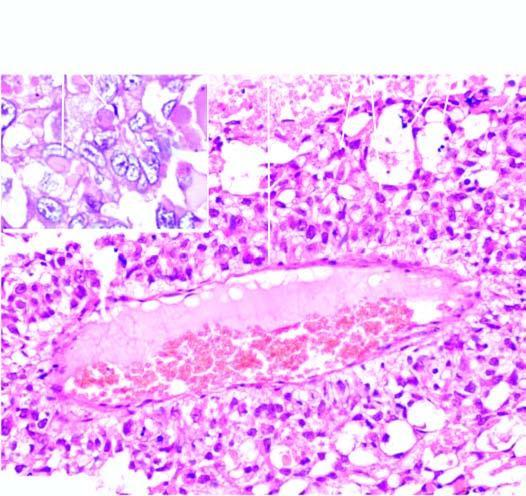what does inset show?
Answer the question using a single word or phrase. Intra- and extracellular hyaline globules 